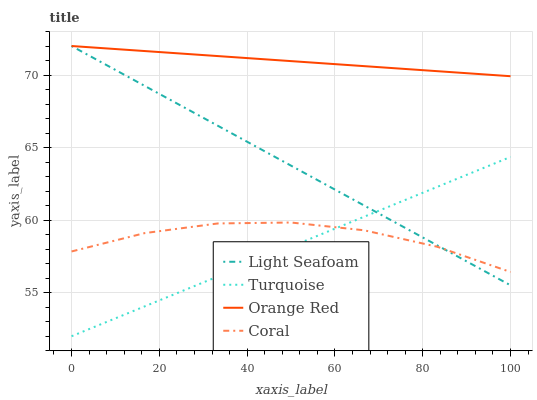Does Turquoise have the minimum area under the curve?
Answer yes or no. Yes. Does Orange Red have the maximum area under the curve?
Answer yes or no. Yes. Does Light Seafoam have the minimum area under the curve?
Answer yes or no. No. Does Light Seafoam have the maximum area under the curve?
Answer yes or no. No. Is Light Seafoam the smoothest?
Answer yes or no. Yes. Is Coral the roughest?
Answer yes or no. Yes. Is Turquoise the smoothest?
Answer yes or no. No. Is Turquoise the roughest?
Answer yes or no. No. Does Turquoise have the lowest value?
Answer yes or no. Yes. Does Light Seafoam have the lowest value?
Answer yes or no. No. Does Orange Red have the highest value?
Answer yes or no. Yes. Does Turquoise have the highest value?
Answer yes or no. No. Is Coral less than Orange Red?
Answer yes or no. Yes. Is Orange Red greater than Turquoise?
Answer yes or no. Yes. Does Light Seafoam intersect Turquoise?
Answer yes or no. Yes. Is Light Seafoam less than Turquoise?
Answer yes or no. No. Is Light Seafoam greater than Turquoise?
Answer yes or no. No. Does Coral intersect Orange Red?
Answer yes or no. No. 